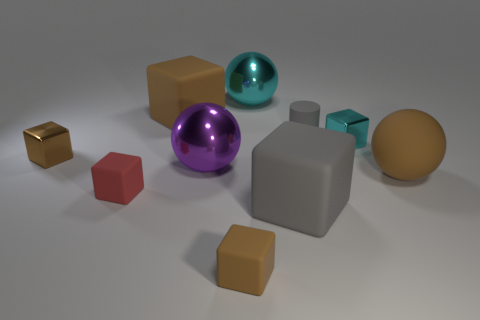What is the color of the cylinder that is the same size as the cyan metallic block?
Ensure brevity in your answer.  Gray. Are there an equal number of brown spheres on the left side of the small red thing and cyan metallic objects?
Ensure brevity in your answer.  No. What is the shape of the object that is to the right of the large cyan metal thing and in front of the large brown sphere?
Ensure brevity in your answer.  Cube. Is the red thing the same size as the gray matte cube?
Your response must be concise. No. Are there any brown blocks that have the same material as the tiny red object?
Make the answer very short. Yes. There is a rubber thing that is the same color as the cylinder; what size is it?
Offer a terse response. Large. What number of objects are both behind the small brown metal cube and on the right side of the big brown cube?
Give a very brief answer. 3. There is a gray object that is on the right side of the large gray thing; what material is it?
Your answer should be very brief. Rubber. How many things have the same color as the rubber sphere?
Ensure brevity in your answer.  3. What size is the purple sphere that is the same material as the large cyan sphere?
Provide a short and direct response. Large. 